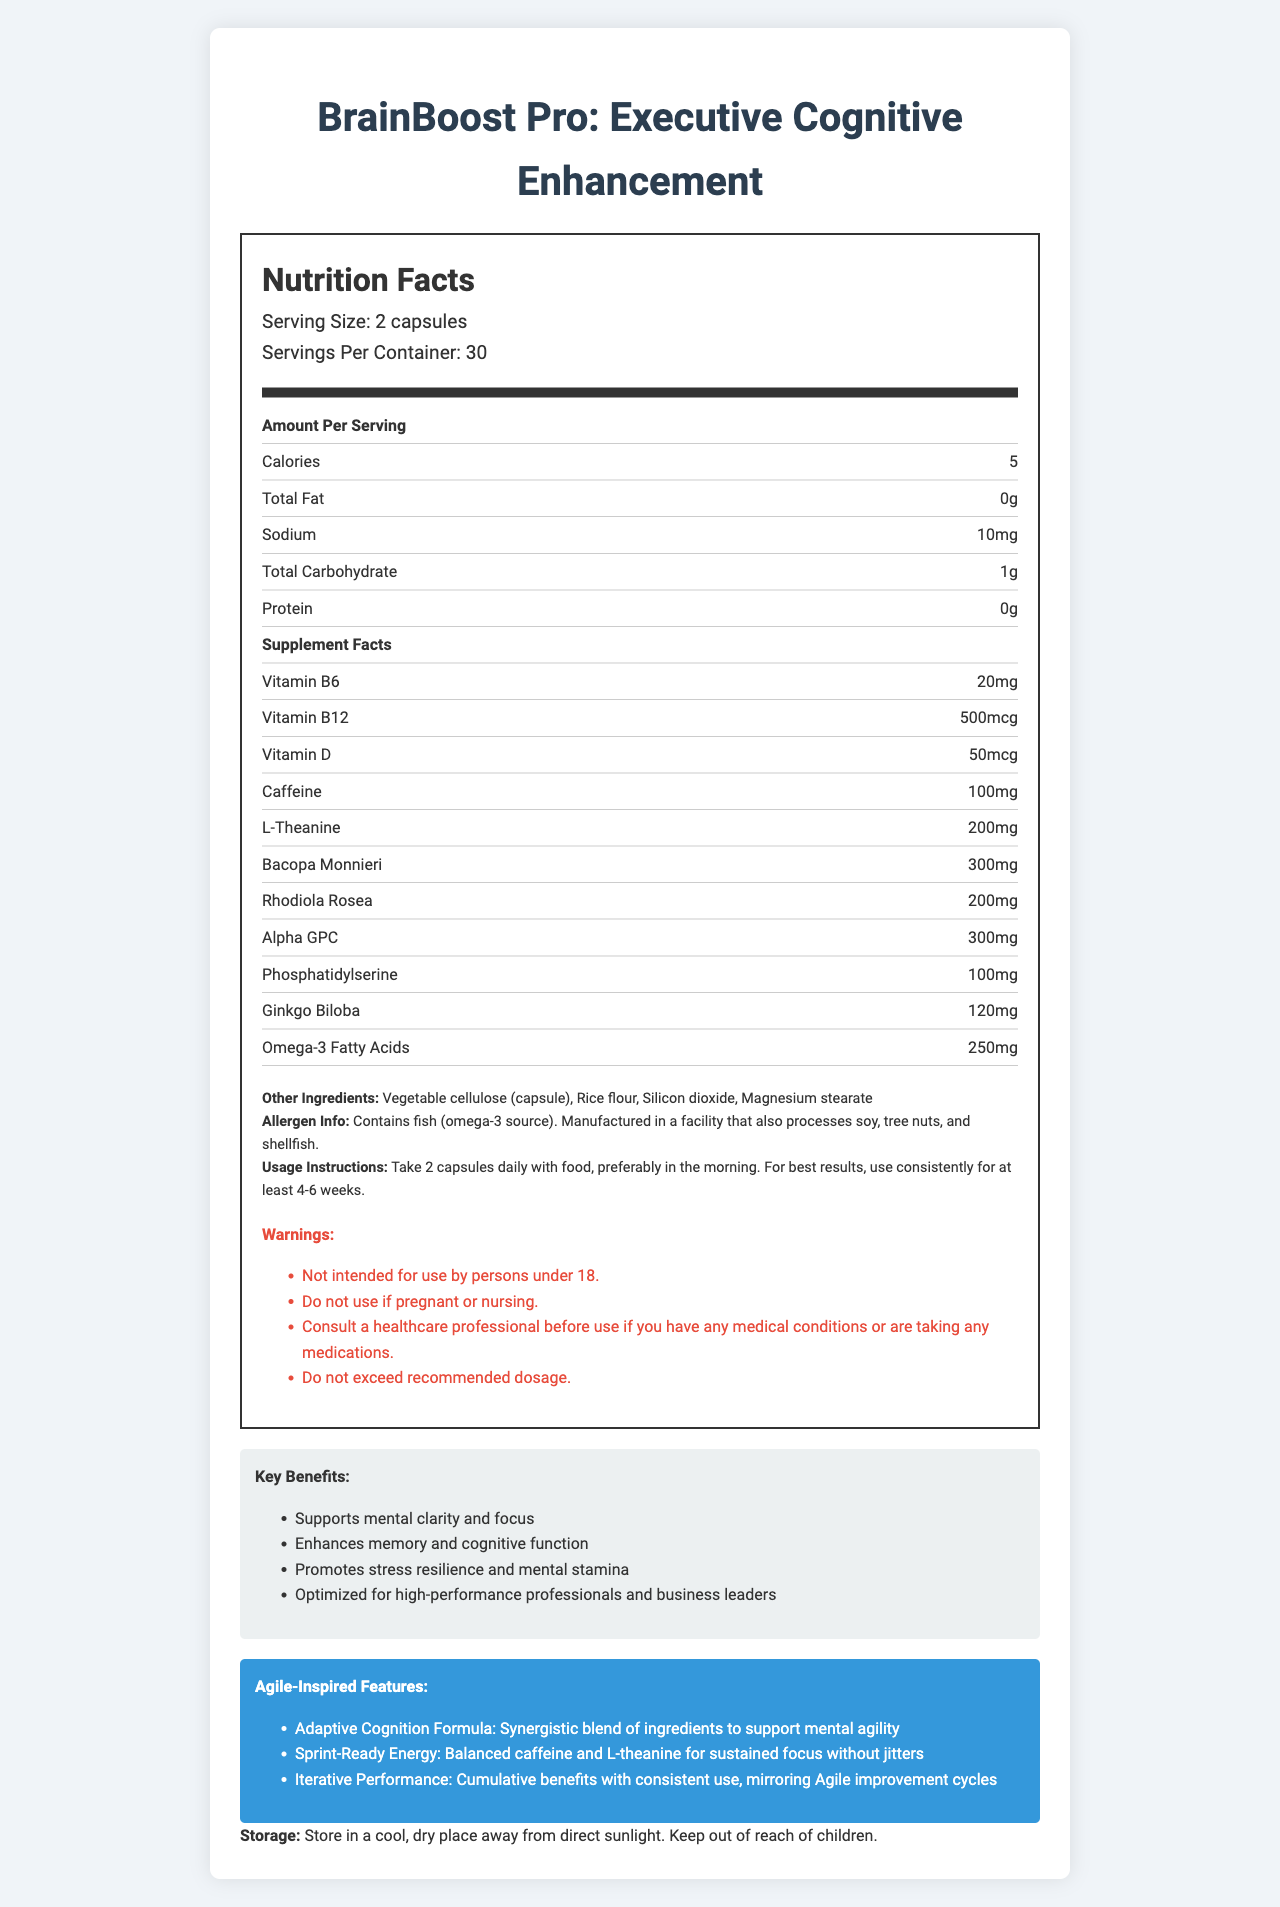what is the serving size for BrainBoost Pro: Executive Cognitive Enhancement? The serving size is listed as "2 capsules" at the beginning of the nutrition label.
Answer: 2 capsules how many calories are in each serving? The number of calories per serving is listed as "5" in the nutrient row.
Answer: 5 what vitamins are present in the supplement? The supplement facts list Vitamin B6, Vitamin B12, and Vitamin D.
Answer: Vitamin B6, Vitamin B12, Vitamin D how much caffeine is in each serving? The amount of caffeine per serving is listed as "100mg" in the supplement facts section.
Answer: 100mg what are some of the other ingredients in this supplement? The other ingredients are listed under the ingredients section.
Answer: Vegetable cellulose (capsule), Rice flour, Silicon dioxide, Magnesium stearate what allergens are mentioned on the label? The allergen information states that the product contains fish (omega-3 source).
Answer: Fish how often should the BrainBoost Pro supplement be taken according to the instructions? The usage instructions state "Take 2 capsules daily with food."
Answer: Daily what is one of the key marketing claims made about this product? A. Promotes weight loss B. Reduces cholesterol C. Supports mental clarity and focus D. Enhances physical strength The marketing claims section includes "Supports mental clarity and focus."
Answer: C which ingredient in the supplement has the highest quantity per serving? A. L-Theanine B. Bacopa Monnieri C. Alpha GPC D. Omega-3 Fatty Acids Bacopa Monnieri has the highest quantity at 300mg, compared to L-Theanine (200mg), Alpha GPC (300mg), and Omega-3 Fatty Acids (250mg).
Answer: B does the supplement contain any protein? The nutrition facts list "0g" of protein per serving.
Answer: No is this supplement intended for anyone under the age of 18? The warnings section states, "Not intended for use by persons under 18."
Answer: No what is the main idea of the document? The document provides detailed information about the BrainBoost Pro supplement, including its nutritional content, ingredients, usage instructions, marketing claims, and storage instructions.
Answer: BrainBoost Pro: Executive Cognitive Enhancement is a nootropic supplement designed to support mental clarity, focus, memory, and cognitive function for business leaders. It includes a variety of vitamins, amino acids, and herbal extracts, with specific instructions, allergen warnings, and marketing claims. what is the exact quantity of silicon dioxide in the supplement? The document lists silicon dioxide as one of the other ingredients but does not provide the exact quantity.
Answer: Not enough information what does the warning section advise about exceeding the recommended dosage? The warning section includes a specific statement: "Do not exceed recommended dosage."
Answer: Do not exceed recommended dosage 